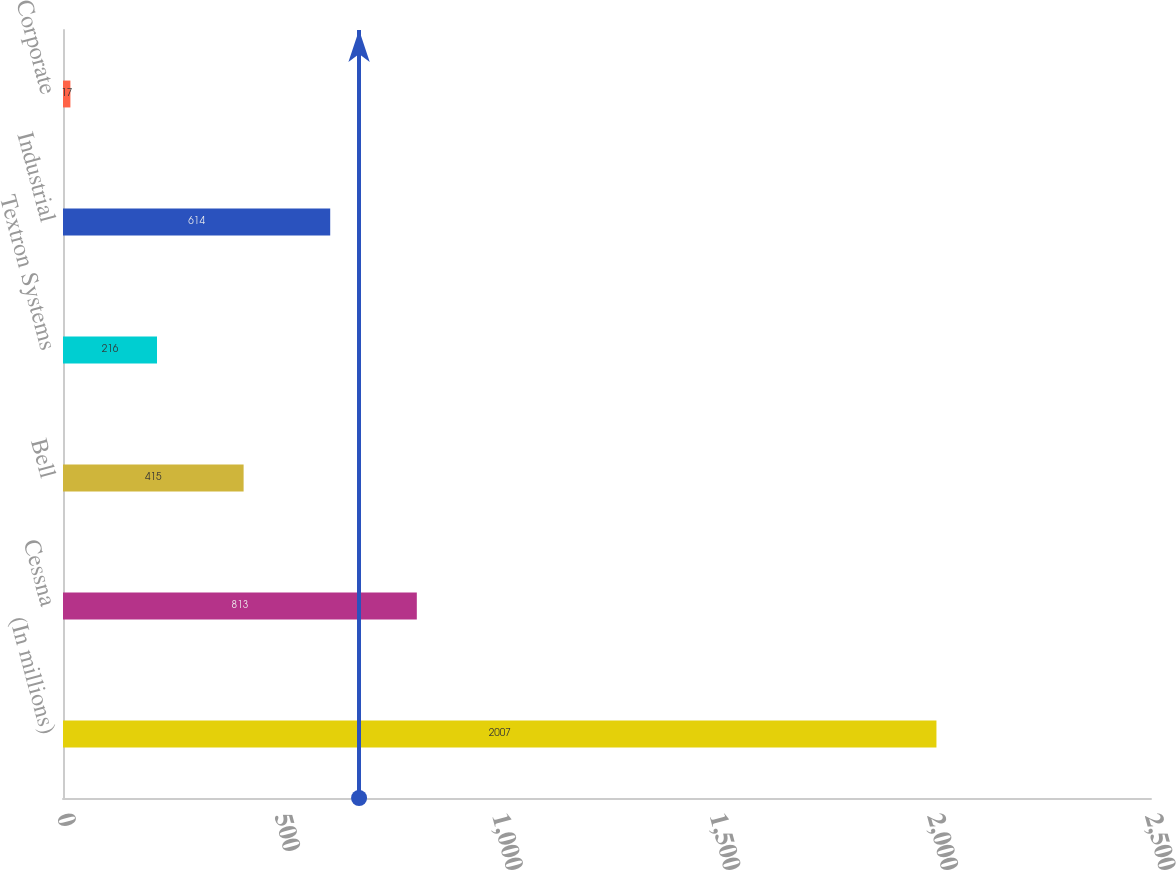<chart> <loc_0><loc_0><loc_500><loc_500><bar_chart><fcel>(In millions)<fcel>Cessna<fcel>Bell<fcel>Textron Systems<fcel>Industrial<fcel>Corporate<nl><fcel>2007<fcel>813<fcel>415<fcel>216<fcel>614<fcel>17<nl></chart> 